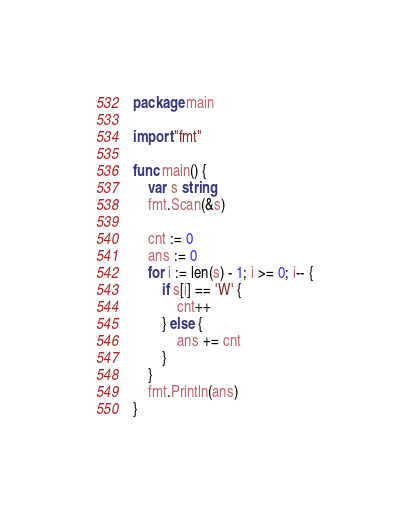Convert code to text. <code><loc_0><loc_0><loc_500><loc_500><_Go_>package main

import "fmt"

func main() {
	var s string
	fmt.Scan(&s)

	cnt := 0
	ans := 0
	for i := len(s) - 1; i >= 0; i-- {
		if s[i] == 'W' {
			cnt++
		} else {
			ans += cnt
		}
	}
	fmt.Println(ans)
}
</code> 